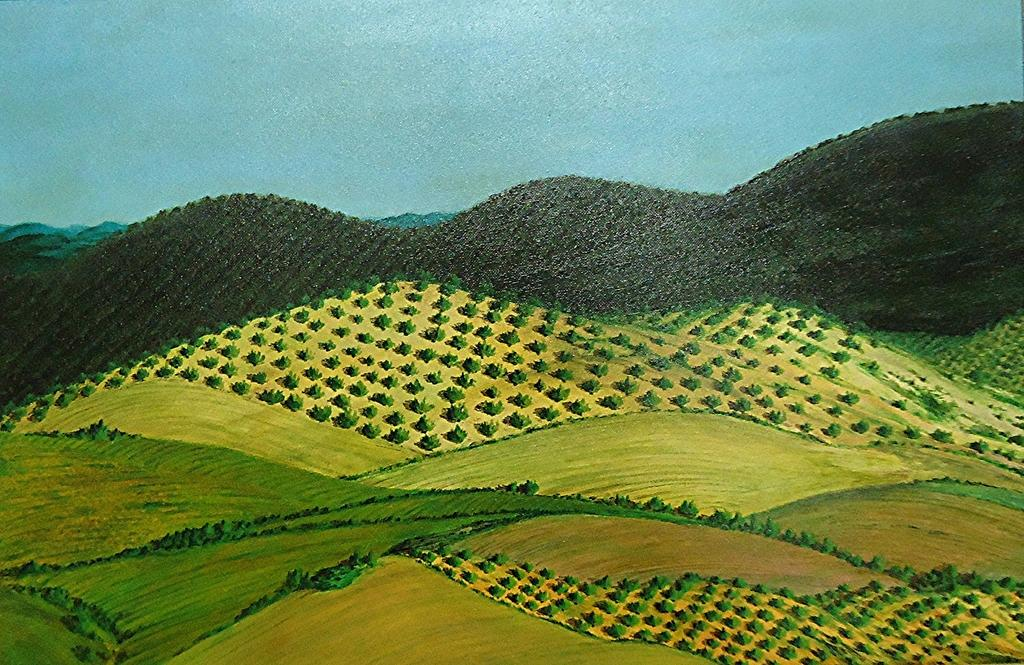What is the main subject of the painting? The painting depicts greenery grass. Are there any other natural features in the painting? Yes, the painting includes mountains. What color is the sky in the painting? The sky in the painting is blue. How many bikes are parked near the mountains in the painting? There are no bikes present in the painting; it only depicts greenery grass, mountains, and a blue sky. Are there any horses grazing in the grass in the painting? There are no horses visible in the painting; it only depicts greenery grass, mountains, and a blue sky. 